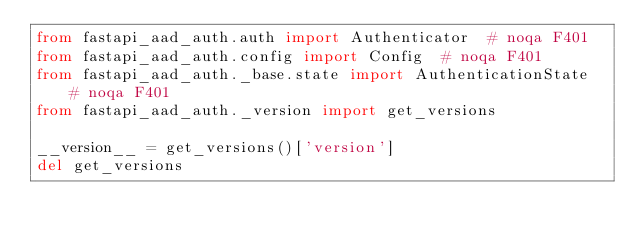<code> <loc_0><loc_0><loc_500><loc_500><_Python_>from fastapi_aad_auth.auth import Authenticator  # noqa F401
from fastapi_aad_auth.config import Config  # noqa F401
from fastapi_aad_auth._base.state import AuthenticationState  # noqa F401
from fastapi_aad_auth._version import get_versions

__version__ = get_versions()['version']
del get_versions
</code> 